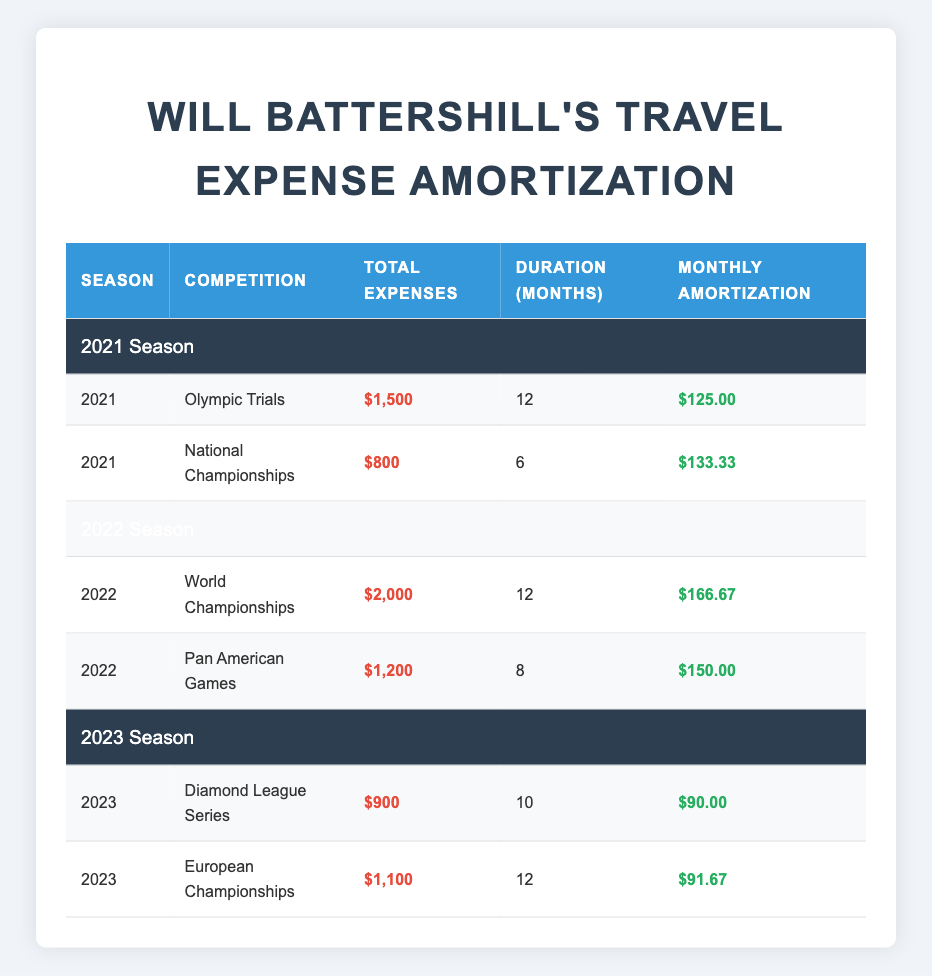What were Will Battershill's total travel expenses for the National Championships in 2021? The table lists the total travel expenses for each competition. For the National Championships in 2021, the total travel expenses are $800.
Answer: $800 How long was the duration for the World Championships in 2022? In the table, the duration for the World Championships in 2022 is shown as 12 months.
Answer: 12 months Which competition had the highest total travel expenses in 2022? The total travel expenses for the World Championships in 2022 are $2000, while the Pan American Games had $1200. Therefore, the World Championships had the highest total travel expenses.
Answer: World Championships What is the average monthly amortization for the competitions in the 2023 season? There are two competitions in the 2023 season: the Diamond League Series with a monthly amortization of $90 and the European Championships with $91.67. The average is calculated as (90 + 91.67) / 2 = 90.83.
Answer: $90.83 Is the monthly amortization for the Olympic Trials in 2021 greater than $100? The monthly amortization for the Olympic Trials in 2021 is listed as $125. Since $125 is greater than $100, the statement is true.
Answer: Yes What are the total travel expenses for competitions in 2021 combined? The total expenses for 2021 are $1500 (Olympic Trials) + $800 (National Championships) = $2300.
Answer: $2300 For which competition was the duration the shortest, and how long was it? The National Championships in 2021 had the shortest duration listed at 6 months. Other competitions had longer durations.
Answer: National Championships, 6 months Was the monthly amortization for the Pan American Games in 2022 higher than that for the Diamond League Series in 2023? The monthly amortization for the Pan American Games in 2022 is $150, while for the Diamond League Series in 2023, it is $90. Since $150 is higher than $90, the statement is true.
Answer: Yes What was the total amortization amount for all competitions in 2022? The total amortization for 2022 is calculated by adding the monthly amortization of both competitions: $166.67 (World Championships) * 12 + $150 (Pan American Games) * 8 = $2000 + $1200 = $3200.
Answer: $3200 